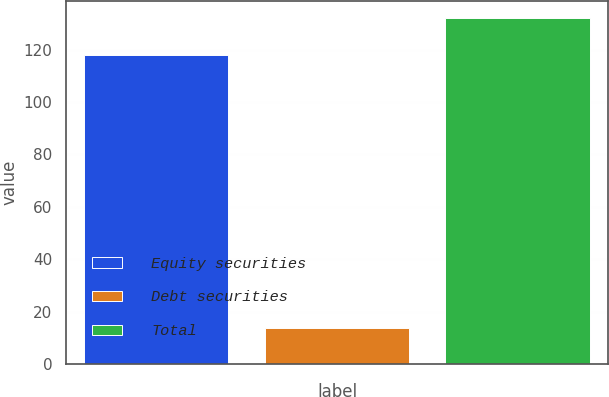Convert chart. <chart><loc_0><loc_0><loc_500><loc_500><bar_chart><fcel>Equity securities<fcel>Debt securities<fcel>Total<nl><fcel>118<fcel>14<fcel>132<nl></chart> 